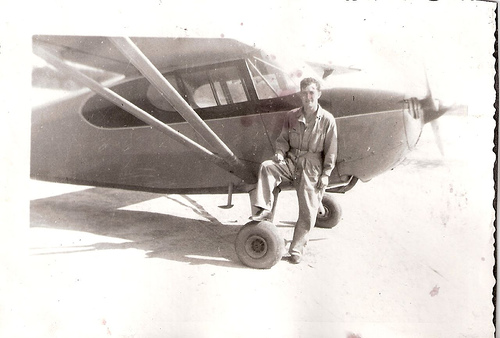<image>
Can you confirm if the man is on the airplane? No. The man is not positioned on the airplane. They may be near each other, but the man is not supported by or resting on top of the airplane. 